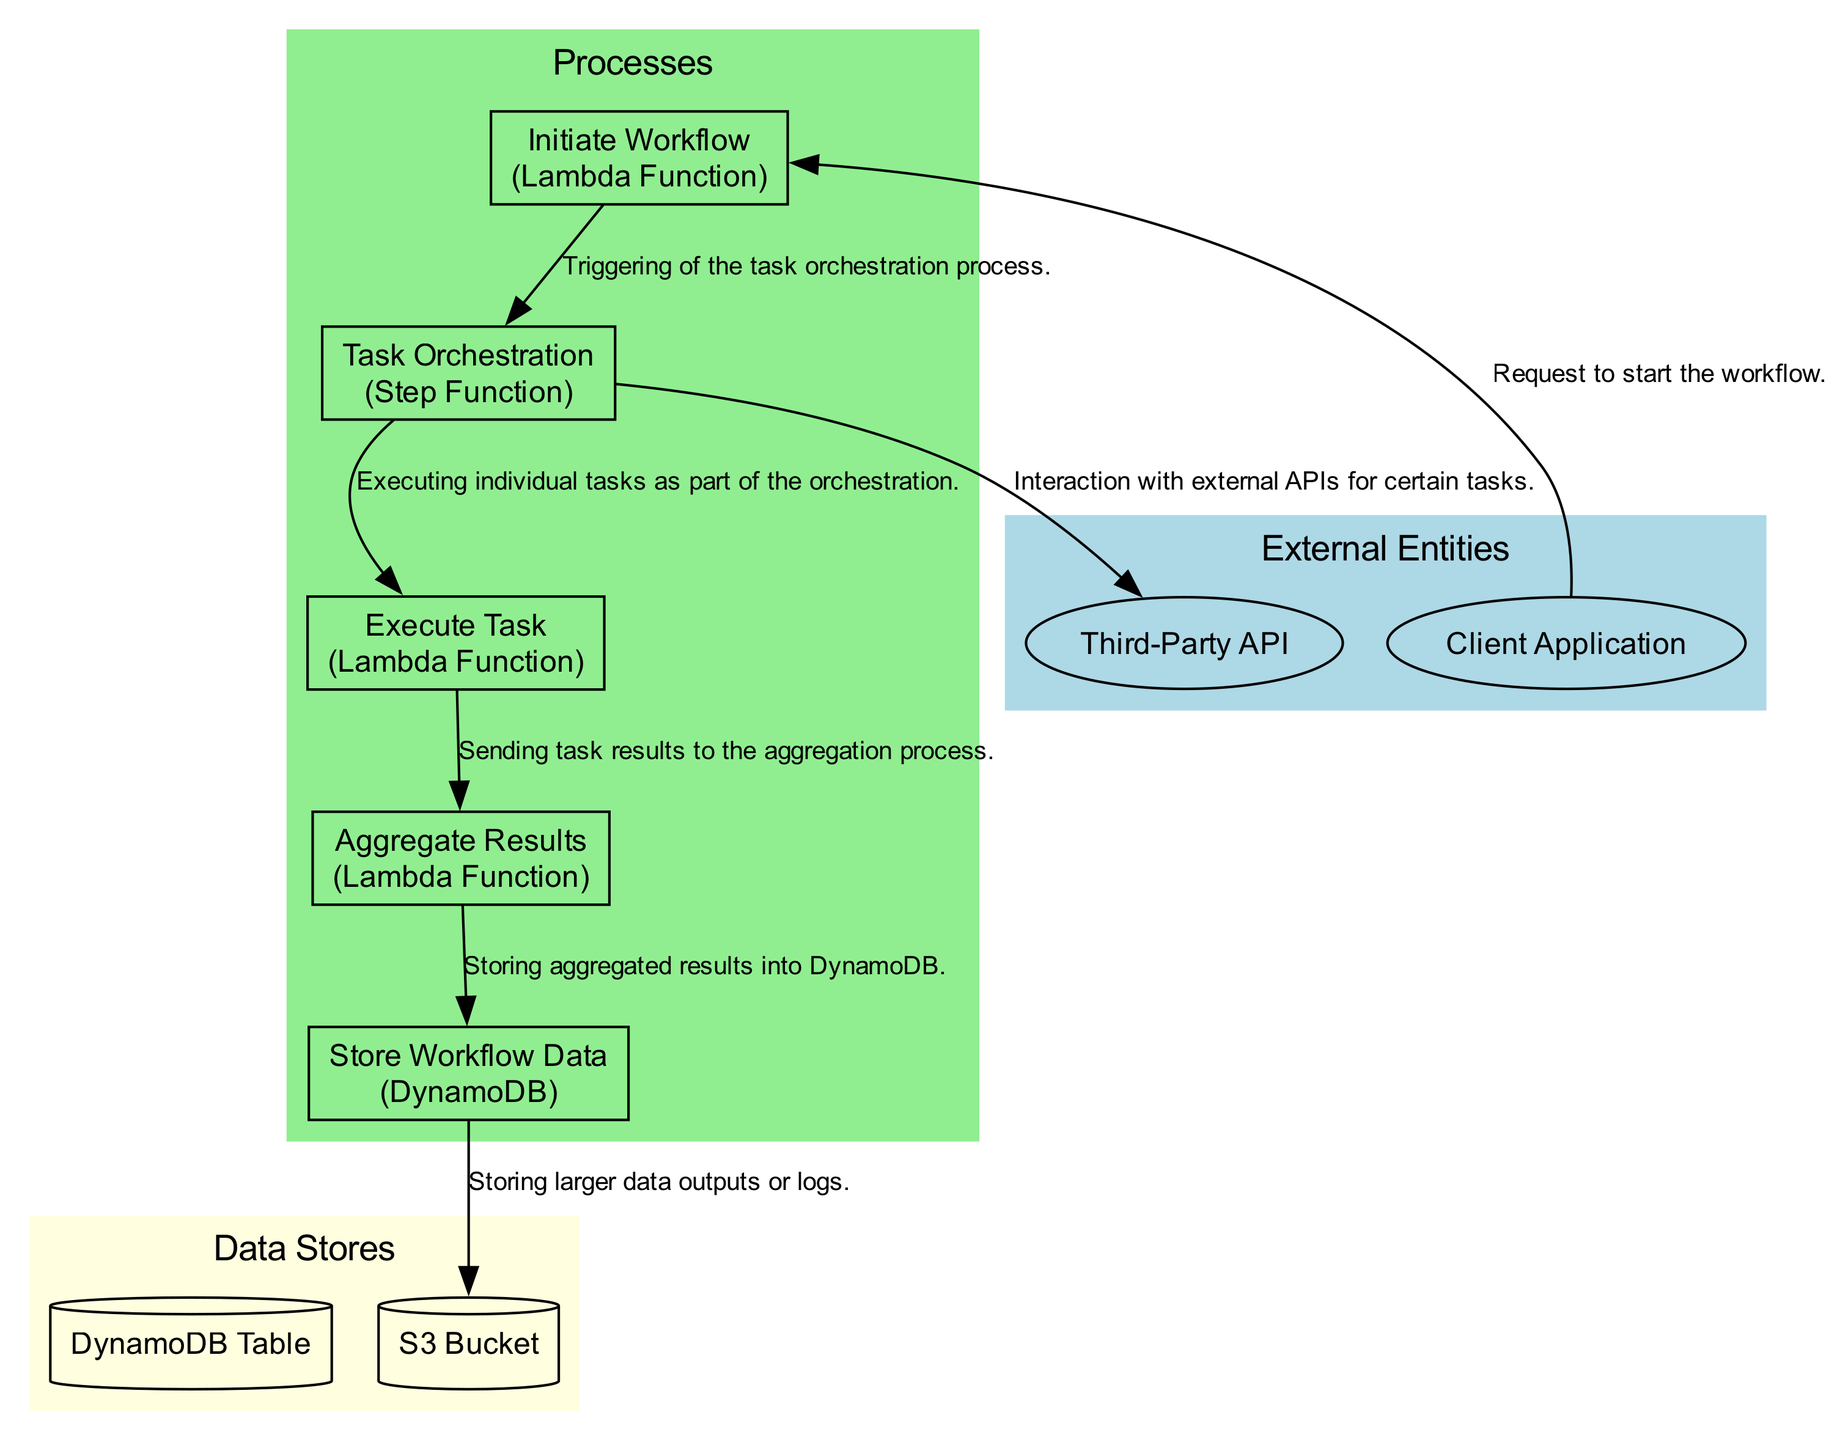What's the number of external entities in the diagram? There are two external entities listed in the diagram: Client Application and Third-Party API.
Answer: 2 What type of process is "Initiate Workflow"? The "Initiate Workflow" process is identified as a Lambda Function in the diagram.
Answer: Lambda Function Which entity initiates the workflow? The workflow is initiated by the Client Application as per the data flow depicted in the diagram.
Answer: Client Application What is the final process that stores data? The final process that involves storing data is "Store Workflow Data", which saves results to a persistent storage.
Answer: Store Workflow Data How many processes are shown in the diagram? The diagram includes five processes which are Initiate Workflow, Task Orchestration, Execute Task, Aggregate Results, and Store Workflow Data.
Answer: 5 What follows the "Execute Task" process? Following the "Execute Task" process is the "Aggregate Results" process, which collects the results from the executed tasks.
Answer: Aggregate Results Which process interacts with an external API? The process that interacts with an external API is identified as "Task Orchestration" in the diagram.
Answer: Task Orchestration What is the data store used for workflow data? The data store designated for storing workflow data is DynamoDB, as mentioned in the diagram.
Answer: DynamoDB How does the "Aggregate Results" process contribute to data storage? The "Aggregate Results" process contributes by sending aggregated results to the "Store Workflow Data" process, which then stores it in a database.
Answer: By sending results to "Store Workflow Data" 